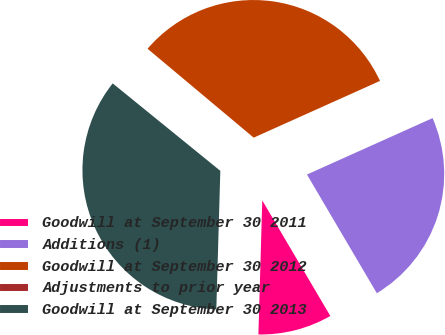Convert chart to OTSL. <chart><loc_0><loc_0><loc_500><loc_500><pie_chart><fcel>Goodwill at September 30 2011<fcel>Additions (1)<fcel>Goodwill at September 30 2012<fcel>Adjustments to prior year<fcel>Goodwill at September 30 2013<nl><fcel>8.93%<fcel>23.25%<fcel>32.18%<fcel>0.24%<fcel>35.4%<nl></chart> 